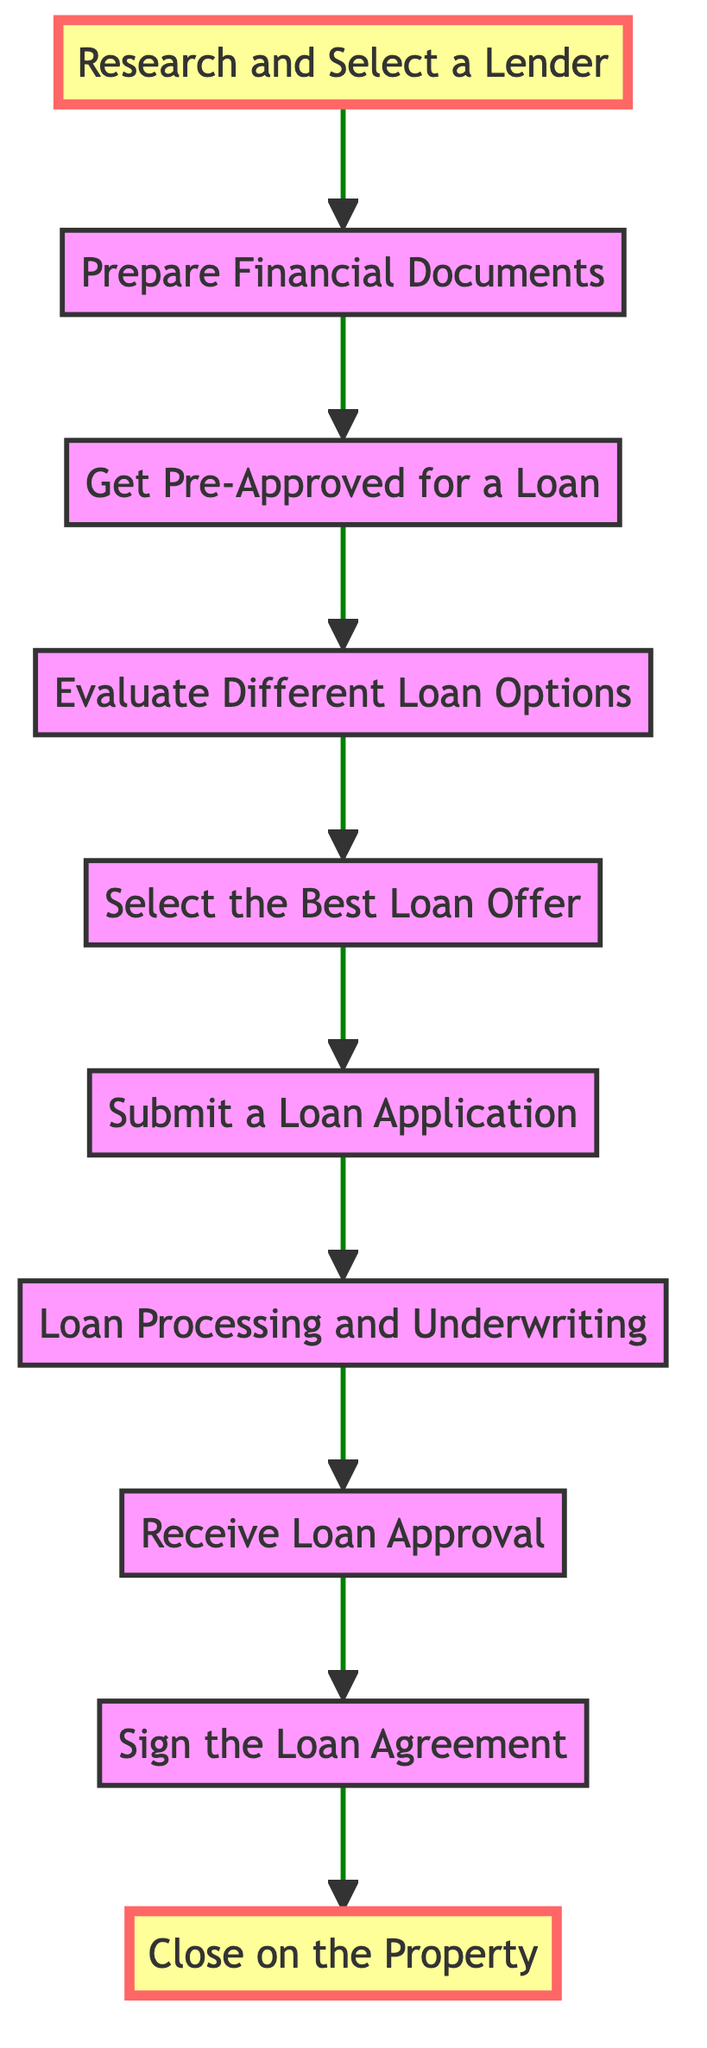What is the first step in the flowchart? The first step in the flowchart is labeled "1" and is "Research and Select a Lender." It is the starting point of the process.
Answer: Research and Select a Lender How many steps are in the flowchart? The flowchart consists of ten distinct steps, as indicated by the labeled nodes numbered from 1 to 10.
Answer: 10 What comes immediately after "Prepare Financial Documents"? The step that follows "Prepare Financial Documents," which is labeled as step "2," is "Get Pre-Approved for a Loan," labeled as step "3."
Answer: Get Pre-Approved for a Loan What is the final step of the process? The final step, labeled as "10," is "Close on the Property," which signifies the completion of the financing process.
Answer: Close on the Property Which step involves submitting a formal loan application? The step that involves this action is labeled as "Submit a Loan Application," which is step "6" in the diagram.
Answer: Submit a Loan Application What two steps come before "Sign the Loan Agreement"? The two steps before "Sign the Loan Agreement," which is labeled "9," are "Receive Loan Approval" (step "8") and "Loan Processing and Underwriting" (step "7").
Answer: Receive Loan Approval and Loan Processing and Underwriting What do you do after "Evaluate Different Loan Options"? The next step after "Evaluate Different Loan Options," which is labeled "4," is "Select the Best Loan Offer," labeled as step "5."
Answer: Select the Best Loan Offer What two steps are highlighted in the diagram? The two highlighted steps in the diagram are "Research and Select a Lender" (step "1") and "Close on the Property" (step "10").
Answer: Research and Select a Lender and Close on the Property What is evaluated in step four? In step "4," the process evaluates different loan types such as conventional loans, FHA loans, and VA loans, considering relevant factors like down payment requirements and loan duration.
Answer: Different loan options 